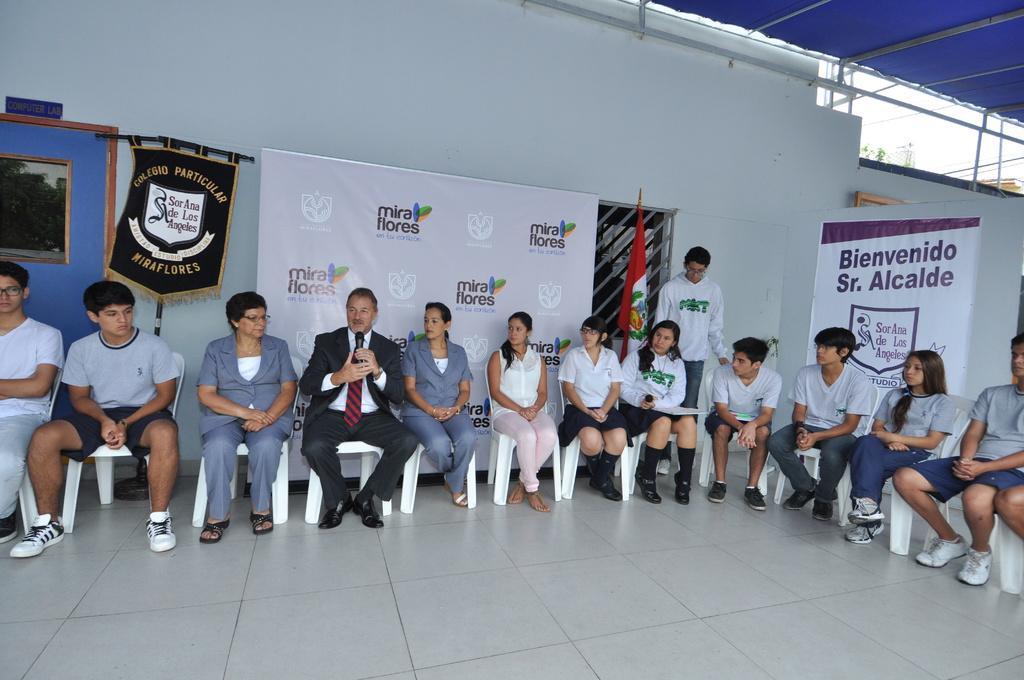Could you give a brief overview of what you see in this image? In this image we can see a group of people sitting on the chairs. In that a man and a woman are holding the mikes. On the backside we can see the flag, a person standing, some banners with text on them, a window with a metal grill, wall, a door, name plate, some wires, a roof with some metal poles and the sky. 